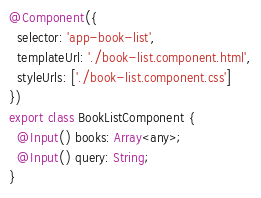Convert code to text. <code><loc_0><loc_0><loc_500><loc_500><_TypeScript_>
@Component({
  selector: 'app-book-list',
  templateUrl: './book-list.component.html',
  styleUrls: ['./book-list.component.css']
})
export class BookListComponent {
  @Input() books: Array<any>;
  @Input() query: String;
}
</code> 